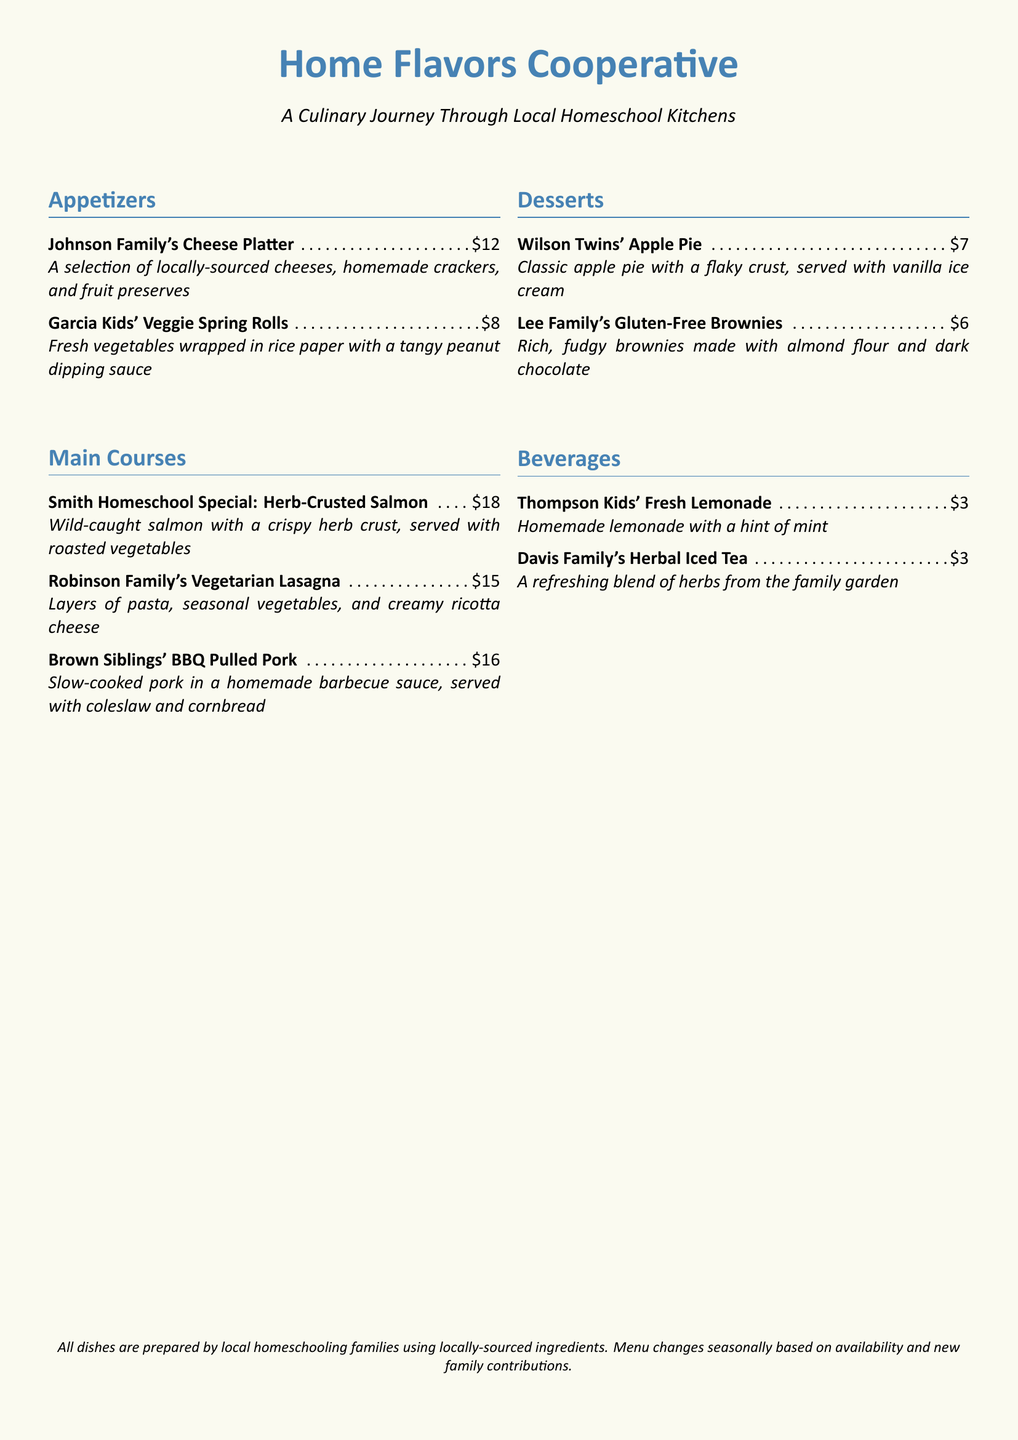What is the name of the culinary collaboration? It is indicated as "Home Flavors Cooperative" in the title of the document.
Answer: Home Flavors Cooperative What is the price of the Johnson Family's Cheese Platter? The price of the Johnson Family's Cheese Platter is listed next to the dish in the Appetizers section.
Answer: $12 Which family contributes the Vegetarian Lasagna? The name of the family who contributed this dish is mentioned before the dish's name in the Main Courses section.
Answer: Robinson Family How much does the Herbal Iced Tea cost? The cost of the Herbal Iced Tea is provided next to the dish in the Beverages section.
Answer: $3 What type of crust is used in the Wilson Twins' Apple Pie? The type of crust is mentioned as "flaky" in the description of the dish.
Answer: Flaky Which dish includes a hint of mint? This refers to the Thompson Kids' Fresh Lemonade based on the description provided in the menu.
Answer: Thompson Kids' Fresh Lemonade How many sections are in the menu? The menu includes four distinct sections: Appetizers, Main Courses, Desserts, and Beverages.
Answer: Four What ingredient is used in the Gluten-Free Brownies? The key ingredient for the Gluten-Free Brownies is noted in the description, specifying the type of flour utilized.
Answer: Almond flour Which family is responsible for the BBQ Pulled Pork dish? The family named before the dish in the Main Courses section is responsible for it.
Answer: Brown Siblings 